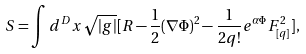Convert formula to latex. <formula><loc_0><loc_0><loc_500><loc_500>S = \int d ^ { D } x \sqrt { | g | } [ R - \frac { 1 } { 2 } ( \nabla \Phi ) ^ { 2 } - \frac { 1 } { 2 q ! } e ^ { \alpha \Phi } F _ { [ q ] } ^ { 2 } ] ,</formula> 